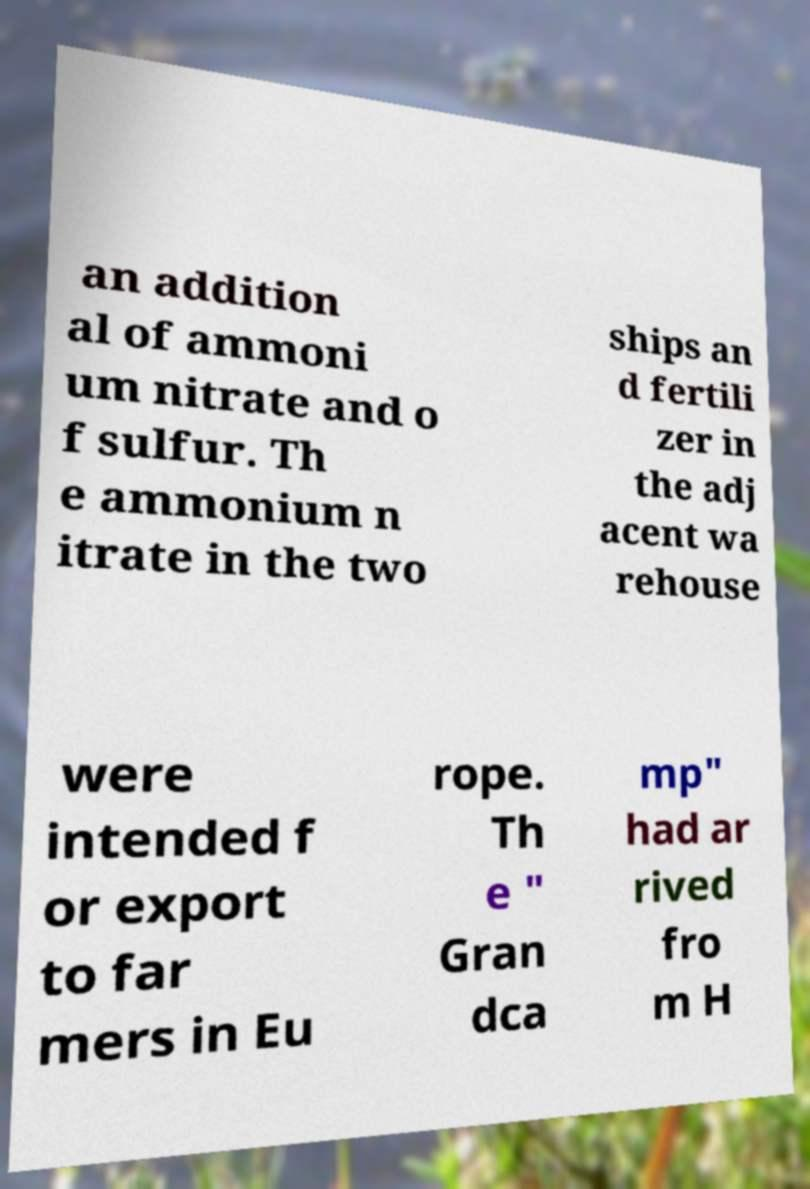Please read and relay the text visible in this image. What does it say? an addition al of ammoni um nitrate and o f sulfur. Th e ammonium n itrate in the two ships an d fertili zer in the adj acent wa rehouse were intended f or export to far mers in Eu rope. Th e " Gran dca mp" had ar rived fro m H 